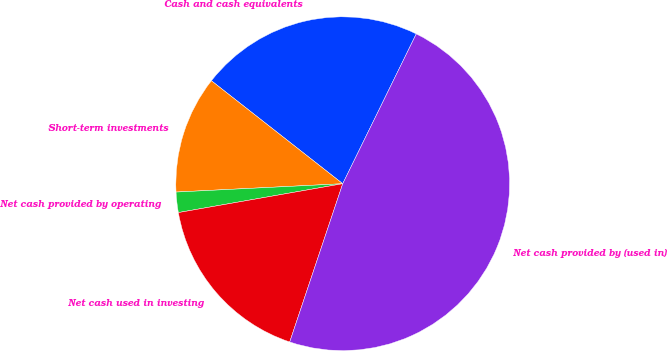Convert chart to OTSL. <chart><loc_0><loc_0><loc_500><loc_500><pie_chart><fcel>Cash and cash equivalents<fcel>Short-term investments<fcel>Net cash provided by operating<fcel>Net cash used in investing<fcel>Net cash provided by (used in)<nl><fcel>21.68%<fcel>11.38%<fcel>1.97%<fcel>17.09%<fcel>47.88%<nl></chart> 